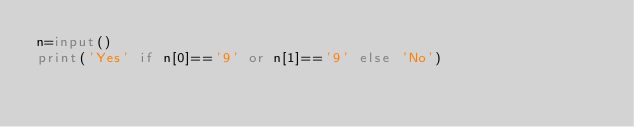<code> <loc_0><loc_0><loc_500><loc_500><_Python_>n=input()
print('Yes' if n[0]=='9' or n[1]=='9' else 'No')</code> 